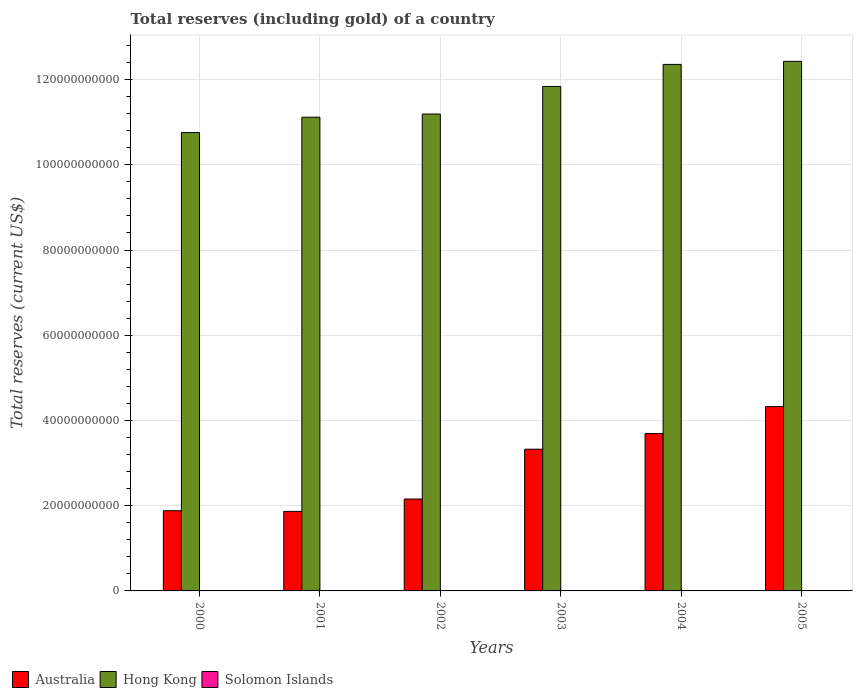How many bars are there on the 3rd tick from the right?
Offer a terse response. 3. What is the label of the 2nd group of bars from the left?
Keep it short and to the point. 2001. In how many cases, is the number of bars for a given year not equal to the number of legend labels?
Give a very brief answer. 0. What is the total reserves (including gold) in Hong Kong in 2005?
Offer a very short reply. 1.24e+11. Across all years, what is the maximum total reserves (including gold) in Solomon Islands?
Keep it short and to the point. 9.48e+07. Across all years, what is the minimum total reserves (including gold) in Australia?
Your answer should be compact. 1.87e+1. What is the total total reserves (including gold) in Australia in the graph?
Your answer should be very brief. 1.72e+11. What is the difference between the total reserves (including gold) in Australia in 2001 and that in 2002?
Offer a terse response. -2.90e+09. What is the difference between the total reserves (including gold) in Hong Kong in 2003 and the total reserves (including gold) in Australia in 2001?
Keep it short and to the point. 9.97e+1. What is the average total reserves (including gold) in Solomon Islands per year?
Provide a succinct answer. 4.67e+07. In the year 2003, what is the difference between the total reserves (including gold) in Solomon Islands and total reserves (including gold) in Hong Kong?
Give a very brief answer. -1.18e+11. In how many years, is the total reserves (including gold) in Hong Kong greater than 36000000000 US$?
Offer a terse response. 6. What is the ratio of the total reserves (including gold) in Solomon Islands in 2000 to that in 2001?
Give a very brief answer. 1.77. What is the difference between the highest and the second highest total reserves (including gold) in Australia?
Offer a terse response. 6.33e+09. What is the difference between the highest and the lowest total reserves (including gold) in Solomon Islands?
Offer a very short reply. 7.68e+07. In how many years, is the total reserves (including gold) in Australia greater than the average total reserves (including gold) in Australia taken over all years?
Give a very brief answer. 3. What does the 3rd bar from the left in 2003 represents?
Your answer should be compact. Solomon Islands. What does the 2nd bar from the right in 2003 represents?
Your response must be concise. Hong Kong. Is it the case that in every year, the sum of the total reserves (including gold) in Australia and total reserves (including gold) in Hong Kong is greater than the total reserves (including gold) in Solomon Islands?
Provide a succinct answer. Yes. How many bars are there?
Keep it short and to the point. 18. Are all the bars in the graph horizontal?
Give a very brief answer. No. How many years are there in the graph?
Give a very brief answer. 6. What is the difference between two consecutive major ticks on the Y-axis?
Your response must be concise. 2.00e+1. Are the values on the major ticks of Y-axis written in scientific E-notation?
Your response must be concise. No. Does the graph contain any zero values?
Provide a succinct answer. No. Does the graph contain grids?
Make the answer very short. Yes. Where does the legend appear in the graph?
Give a very brief answer. Bottom left. How many legend labels are there?
Make the answer very short. 3. What is the title of the graph?
Give a very brief answer. Total reserves (including gold) of a country. Does "Chile" appear as one of the legend labels in the graph?
Your answer should be very brief. No. What is the label or title of the Y-axis?
Your response must be concise. Total reserves (current US$). What is the Total reserves (current US$) in Australia in 2000?
Give a very brief answer. 1.88e+1. What is the Total reserves (current US$) of Hong Kong in 2000?
Make the answer very short. 1.08e+11. What is the Total reserves (current US$) of Solomon Islands in 2000?
Keep it short and to the point. 3.20e+07. What is the Total reserves (current US$) of Australia in 2001?
Provide a short and direct response. 1.87e+1. What is the Total reserves (current US$) in Hong Kong in 2001?
Keep it short and to the point. 1.11e+11. What is the Total reserves (current US$) of Solomon Islands in 2001?
Provide a short and direct response. 1.81e+07. What is the Total reserves (current US$) of Australia in 2002?
Provide a succinct answer. 2.16e+1. What is the Total reserves (current US$) in Hong Kong in 2002?
Provide a short and direct response. 1.12e+11. What is the Total reserves (current US$) of Solomon Islands in 2002?
Your answer should be very brief. 1.87e+07. What is the Total reserves (current US$) of Australia in 2003?
Offer a very short reply. 3.33e+1. What is the Total reserves (current US$) of Hong Kong in 2003?
Offer a very short reply. 1.18e+11. What is the Total reserves (current US$) in Solomon Islands in 2003?
Offer a very short reply. 3.70e+07. What is the Total reserves (current US$) in Australia in 2004?
Your response must be concise. 3.69e+1. What is the Total reserves (current US$) in Hong Kong in 2004?
Your answer should be compact. 1.24e+11. What is the Total reserves (current US$) of Solomon Islands in 2004?
Make the answer very short. 7.98e+07. What is the Total reserves (current US$) of Australia in 2005?
Ensure brevity in your answer.  4.33e+1. What is the Total reserves (current US$) of Hong Kong in 2005?
Provide a short and direct response. 1.24e+11. What is the Total reserves (current US$) of Solomon Islands in 2005?
Give a very brief answer. 9.48e+07. Across all years, what is the maximum Total reserves (current US$) in Australia?
Give a very brief answer. 4.33e+1. Across all years, what is the maximum Total reserves (current US$) in Hong Kong?
Make the answer very short. 1.24e+11. Across all years, what is the maximum Total reserves (current US$) in Solomon Islands?
Your answer should be very brief. 9.48e+07. Across all years, what is the minimum Total reserves (current US$) in Australia?
Keep it short and to the point. 1.87e+1. Across all years, what is the minimum Total reserves (current US$) of Hong Kong?
Offer a terse response. 1.08e+11. Across all years, what is the minimum Total reserves (current US$) of Solomon Islands?
Your answer should be very brief. 1.81e+07. What is the total Total reserves (current US$) of Australia in the graph?
Provide a succinct answer. 1.72e+11. What is the total Total reserves (current US$) in Hong Kong in the graph?
Offer a terse response. 6.97e+11. What is the total Total reserves (current US$) of Solomon Islands in the graph?
Offer a terse response. 2.80e+08. What is the difference between the Total reserves (current US$) of Australia in 2000 and that in 2001?
Your answer should be very brief. 1.58e+08. What is the difference between the Total reserves (current US$) of Hong Kong in 2000 and that in 2001?
Your answer should be very brief. -3.61e+09. What is the difference between the Total reserves (current US$) of Solomon Islands in 2000 and that in 2001?
Offer a very short reply. 1.40e+07. What is the difference between the Total reserves (current US$) in Australia in 2000 and that in 2002?
Offer a very short reply. -2.75e+09. What is the difference between the Total reserves (current US$) of Hong Kong in 2000 and that in 2002?
Your answer should be very brief. -4.36e+09. What is the difference between the Total reserves (current US$) in Solomon Islands in 2000 and that in 2002?
Offer a very short reply. 1.34e+07. What is the difference between the Total reserves (current US$) in Australia in 2000 and that in 2003?
Ensure brevity in your answer.  -1.44e+1. What is the difference between the Total reserves (current US$) of Hong Kong in 2000 and that in 2003?
Your response must be concise. -1.08e+1. What is the difference between the Total reserves (current US$) of Solomon Islands in 2000 and that in 2003?
Provide a succinct answer. -4.96e+06. What is the difference between the Total reserves (current US$) of Australia in 2000 and that in 2004?
Your answer should be compact. -1.81e+1. What is the difference between the Total reserves (current US$) in Hong Kong in 2000 and that in 2004?
Your answer should be compact. -1.60e+1. What is the difference between the Total reserves (current US$) of Solomon Islands in 2000 and that in 2004?
Your answer should be compact. -4.78e+07. What is the difference between the Total reserves (current US$) of Australia in 2000 and that in 2005?
Ensure brevity in your answer.  -2.44e+1. What is the difference between the Total reserves (current US$) of Hong Kong in 2000 and that in 2005?
Make the answer very short. -1.67e+1. What is the difference between the Total reserves (current US$) of Solomon Islands in 2000 and that in 2005?
Your answer should be very brief. -6.28e+07. What is the difference between the Total reserves (current US$) in Australia in 2001 and that in 2002?
Your answer should be compact. -2.90e+09. What is the difference between the Total reserves (current US$) in Hong Kong in 2001 and that in 2002?
Your answer should be compact. -7.45e+08. What is the difference between the Total reserves (current US$) in Solomon Islands in 2001 and that in 2002?
Keep it short and to the point. -6.17e+05. What is the difference between the Total reserves (current US$) of Australia in 2001 and that in 2003?
Ensure brevity in your answer.  -1.46e+1. What is the difference between the Total reserves (current US$) of Hong Kong in 2001 and that in 2003?
Give a very brief answer. -7.21e+09. What is the difference between the Total reserves (current US$) in Solomon Islands in 2001 and that in 2003?
Offer a terse response. -1.89e+07. What is the difference between the Total reserves (current US$) of Australia in 2001 and that in 2004?
Provide a succinct answer. -1.83e+1. What is the difference between the Total reserves (current US$) in Hong Kong in 2001 and that in 2004?
Your answer should be very brief. -1.24e+1. What is the difference between the Total reserves (current US$) of Solomon Islands in 2001 and that in 2004?
Offer a very short reply. -6.17e+07. What is the difference between the Total reserves (current US$) of Australia in 2001 and that in 2005?
Offer a terse response. -2.46e+1. What is the difference between the Total reserves (current US$) in Hong Kong in 2001 and that in 2005?
Keep it short and to the point. -1.31e+1. What is the difference between the Total reserves (current US$) in Solomon Islands in 2001 and that in 2005?
Offer a terse response. -7.68e+07. What is the difference between the Total reserves (current US$) in Australia in 2002 and that in 2003?
Your answer should be very brief. -1.17e+1. What is the difference between the Total reserves (current US$) in Hong Kong in 2002 and that in 2003?
Your response must be concise. -6.47e+09. What is the difference between the Total reserves (current US$) of Solomon Islands in 2002 and that in 2003?
Your answer should be very brief. -1.83e+07. What is the difference between the Total reserves (current US$) in Australia in 2002 and that in 2004?
Keep it short and to the point. -1.54e+1. What is the difference between the Total reserves (current US$) in Hong Kong in 2002 and that in 2004?
Your response must be concise. -1.17e+1. What is the difference between the Total reserves (current US$) of Solomon Islands in 2002 and that in 2004?
Make the answer very short. -6.11e+07. What is the difference between the Total reserves (current US$) in Australia in 2002 and that in 2005?
Provide a short and direct response. -2.17e+1. What is the difference between the Total reserves (current US$) in Hong Kong in 2002 and that in 2005?
Your answer should be very brief. -1.24e+1. What is the difference between the Total reserves (current US$) in Solomon Islands in 2002 and that in 2005?
Offer a terse response. -7.61e+07. What is the difference between the Total reserves (current US$) of Australia in 2003 and that in 2004?
Make the answer very short. -3.67e+09. What is the difference between the Total reserves (current US$) in Hong Kong in 2003 and that in 2004?
Your answer should be compact. -5.18e+09. What is the difference between the Total reserves (current US$) of Solomon Islands in 2003 and that in 2004?
Your response must be concise. -4.28e+07. What is the difference between the Total reserves (current US$) in Australia in 2003 and that in 2005?
Your answer should be compact. -1.00e+1. What is the difference between the Total reserves (current US$) of Hong Kong in 2003 and that in 2005?
Provide a succinct answer. -5.89e+09. What is the difference between the Total reserves (current US$) in Solomon Islands in 2003 and that in 2005?
Offer a terse response. -5.78e+07. What is the difference between the Total reserves (current US$) in Australia in 2004 and that in 2005?
Your answer should be very brief. -6.33e+09. What is the difference between the Total reserves (current US$) of Hong Kong in 2004 and that in 2005?
Offer a very short reply. -7.09e+08. What is the difference between the Total reserves (current US$) in Solomon Islands in 2004 and that in 2005?
Provide a succinct answer. -1.50e+07. What is the difference between the Total reserves (current US$) in Australia in 2000 and the Total reserves (current US$) in Hong Kong in 2001?
Make the answer very short. -9.24e+1. What is the difference between the Total reserves (current US$) of Australia in 2000 and the Total reserves (current US$) of Solomon Islands in 2001?
Keep it short and to the point. 1.88e+1. What is the difference between the Total reserves (current US$) in Hong Kong in 2000 and the Total reserves (current US$) in Solomon Islands in 2001?
Make the answer very short. 1.08e+11. What is the difference between the Total reserves (current US$) of Australia in 2000 and the Total reserves (current US$) of Hong Kong in 2002?
Your answer should be compact. -9.31e+1. What is the difference between the Total reserves (current US$) of Australia in 2000 and the Total reserves (current US$) of Solomon Islands in 2002?
Offer a terse response. 1.88e+1. What is the difference between the Total reserves (current US$) in Hong Kong in 2000 and the Total reserves (current US$) in Solomon Islands in 2002?
Provide a succinct answer. 1.08e+11. What is the difference between the Total reserves (current US$) in Australia in 2000 and the Total reserves (current US$) in Hong Kong in 2003?
Make the answer very short. -9.96e+1. What is the difference between the Total reserves (current US$) in Australia in 2000 and the Total reserves (current US$) in Solomon Islands in 2003?
Your response must be concise. 1.88e+1. What is the difference between the Total reserves (current US$) of Hong Kong in 2000 and the Total reserves (current US$) of Solomon Islands in 2003?
Offer a terse response. 1.08e+11. What is the difference between the Total reserves (current US$) in Australia in 2000 and the Total reserves (current US$) in Hong Kong in 2004?
Give a very brief answer. -1.05e+11. What is the difference between the Total reserves (current US$) in Australia in 2000 and the Total reserves (current US$) in Solomon Islands in 2004?
Your response must be concise. 1.87e+1. What is the difference between the Total reserves (current US$) in Hong Kong in 2000 and the Total reserves (current US$) in Solomon Islands in 2004?
Your answer should be compact. 1.07e+11. What is the difference between the Total reserves (current US$) in Australia in 2000 and the Total reserves (current US$) in Hong Kong in 2005?
Your answer should be compact. -1.05e+11. What is the difference between the Total reserves (current US$) in Australia in 2000 and the Total reserves (current US$) in Solomon Islands in 2005?
Ensure brevity in your answer.  1.87e+1. What is the difference between the Total reserves (current US$) in Hong Kong in 2000 and the Total reserves (current US$) in Solomon Islands in 2005?
Offer a very short reply. 1.07e+11. What is the difference between the Total reserves (current US$) in Australia in 2001 and the Total reserves (current US$) in Hong Kong in 2002?
Offer a very short reply. -9.33e+1. What is the difference between the Total reserves (current US$) of Australia in 2001 and the Total reserves (current US$) of Solomon Islands in 2002?
Provide a succinct answer. 1.86e+1. What is the difference between the Total reserves (current US$) in Hong Kong in 2001 and the Total reserves (current US$) in Solomon Islands in 2002?
Give a very brief answer. 1.11e+11. What is the difference between the Total reserves (current US$) of Australia in 2001 and the Total reserves (current US$) of Hong Kong in 2003?
Provide a short and direct response. -9.97e+1. What is the difference between the Total reserves (current US$) in Australia in 2001 and the Total reserves (current US$) in Solomon Islands in 2003?
Keep it short and to the point. 1.86e+1. What is the difference between the Total reserves (current US$) of Hong Kong in 2001 and the Total reserves (current US$) of Solomon Islands in 2003?
Offer a very short reply. 1.11e+11. What is the difference between the Total reserves (current US$) of Australia in 2001 and the Total reserves (current US$) of Hong Kong in 2004?
Ensure brevity in your answer.  -1.05e+11. What is the difference between the Total reserves (current US$) of Australia in 2001 and the Total reserves (current US$) of Solomon Islands in 2004?
Offer a very short reply. 1.86e+1. What is the difference between the Total reserves (current US$) of Hong Kong in 2001 and the Total reserves (current US$) of Solomon Islands in 2004?
Ensure brevity in your answer.  1.11e+11. What is the difference between the Total reserves (current US$) of Australia in 2001 and the Total reserves (current US$) of Hong Kong in 2005?
Provide a succinct answer. -1.06e+11. What is the difference between the Total reserves (current US$) in Australia in 2001 and the Total reserves (current US$) in Solomon Islands in 2005?
Offer a terse response. 1.86e+1. What is the difference between the Total reserves (current US$) in Hong Kong in 2001 and the Total reserves (current US$) in Solomon Islands in 2005?
Ensure brevity in your answer.  1.11e+11. What is the difference between the Total reserves (current US$) of Australia in 2002 and the Total reserves (current US$) of Hong Kong in 2003?
Offer a terse response. -9.68e+1. What is the difference between the Total reserves (current US$) of Australia in 2002 and the Total reserves (current US$) of Solomon Islands in 2003?
Your answer should be compact. 2.15e+1. What is the difference between the Total reserves (current US$) of Hong Kong in 2002 and the Total reserves (current US$) of Solomon Islands in 2003?
Provide a short and direct response. 1.12e+11. What is the difference between the Total reserves (current US$) in Australia in 2002 and the Total reserves (current US$) in Hong Kong in 2004?
Give a very brief answer. -1.02e+11. What is the difference between the Total reserves (current US$) of Australia in 2002 and the Total reserves (current US$) of Solomon Islands in 2004?
Give a very brief answer. 2.15e+1. What is the difference between the Total reserves (current US$) in Hong Kong in 2002 and the Total reserves (current US$) in Solomon Islands in 2004?
Ensure brevity in your answer.  1.12e+11. What is the difference between the Total reserves (current US$) of Australia in 2002 and the Total reserves (current US$) of Hong Kong in 2005?
Your answer should be very brief. -1.03e+11. What is the difference between the Total reserves (current US$) of Australia in 2002 and the Total reserves (current US$) of Solomon Islands in 2005?
Provide a succinct answer. 2.15e+1. What is the difference between the Total reserves (current US$) in Hong Kong in 2002 and the Total reserves (current US$) in Solomon Islands in 2005?
Your response must be concise. 1.12e+11. What is the difference between the Total reserves (current US$) in Australia in 2003 and the Total reserves (current US$) in Hong Kong in 2004?
Offer a very short reply. -9.03e+1. What is the difference between the Total reserves (current US$) of Australia in 2003 and the Total reserves (current US$) of Solomon Islands in 2004?
Your answer should be very brief. 3.32e+1. What is the difference between the Total reserves (current US$) of Hong Kong in 2003 and the Total reserves (current US$) of Solomon Islands in 2004?
Provide a succinct answer. 1.18e+11. What is the difference between the Total reserves (current US$) of Australia in 2003 and the Total reserves (current US$) of Hong Kong in 2005?
Make the answer very short. -9.10e+1. What is the difference between the Total reserves (current US$) in Australia in 2003 and the Total reserves (current US$) in Solomon Islands in 2005?
Give a very brief answer. 3.32e+1. What is the difference between the Total reserves (current US$) in Hong Kong in 2003 and the Total reserves (current US$) in Solomon Islands in 2005?
Offer a terse response. 1.18e+11. What is the difference between the Total reserves (current US$) in Australia in 2004 and the Total reserves (current US$) in Hong Kong in 2005?
Make the answer very short. -8.74e+1. What is the difference between the Total reserves (current US$) in Australia in 2004 and the Total reserves (current US$) in Solomon Islands in 2005?
Give a very brief answer. 3.68e+1. What is the difference between the Total reserves (current US$) of Hong Kong in 2004 and the Total reserves (current US$) of Solomon Islands in 2005?
Your answer should be very brief. 1.23e+11. What is the average Total reserves (current US$) in Australia per year?
Make the answer very short. 2.87e+1. What is the average Total reserves (current US$) in Hong Kong per year?
Your answer should be compact. 1.16e+11. What is the average Total reserves (current US$) in Solomon Islands per year?
Offer a very short reply. 4.67e+07. In the year 2000, what is the difference between the Total reserves (current US$) in Australia and Total reserves (current US$) in Hong Kong?
Your response must be concise. -8.87e+1. In the year 2000, what is the difference between the Total reserves (current US$) of Australia and Total reserves (current US$) of Solomon Islands?
Offer a very short reply. 1.88e+1. In the year 2000, what is the difference between the Total reserves (current US$) of Hong Kong and Total reserves (current US$) of Solomon Islands?
Make the answer very short. 1.08e+11. In the year 2001, what is the difference between the Total reserves (current US$) of Australia and Total reserves (current US$) of Hong Kong?
Offer a terse response. -9.25e+1. In the year 2001, what is the difference between the Total reserves (current US$) of Australia and Total reserves (current US$) of Solomon Islands?
Ensure brevity in your answer.  1.86e+1. In the year 2001, what is the difference between the Total reserves (current US$) in Hong Kong and Total reserves (current US$) in Solomon Islands?
Your response must be concise. 1.11e+11. In the year 2002, what is the difference between the Total reserves (current US$) in Australia and Total reserves (current US$) in Hong Kong?
Make the answer very short. -9.04e+1. In the year 2002, what is the difference between the Total reserves (current US$) in Australia and Total reserves (current US$) in Solomon Islands?
Make the answer very short. 2.15e+1. In the year 2002, what is the difference between the Total reserves (current US$) of Hong Kong and Total reserves (current US$) of Solomon Islands?
Ensure brevity in your answer.  1.12e+11. In the year 2003, what is the difference between the Total reserves (current US$) of Australia and Total reserves (current US$) of Hong Kong?
Provide a short and direct response. -8.51e+1. In the year 2003, what is the difference between the Total reserves (current US$) of Australia and Total reserves (current US$) of Solomon Islands?
Offer a terse response. 3.32e+1. In the year 2003, what is the difference between the Total reserves (current US$) in Hong Kong and Total reserves (current US$) in Solomon Islands?
Give a very brief answer. 1.18e+11. In the year 2004, what is the difference between the Total reserves (current US$) in Australia and Total reserves (current US$) in Hong Kong?
Your answer should be compact. -8.66e+1. In the year 2004, what is the difference between the Total reserves (current US$) of Australia and Total reserves (current US$) of Solomon Islands?
Your response must be concise. 3.68e+1. In the year 2004, what is the difference between the Total reserves (current US$) of Hong Kong and Total reserves (current US$) of Solomon Islands?
Offer a very short reply. 1.23e+11. In the year 2005, what is the difference between the Total reserves (current US$) in Australia and Total reserves (current US$) in Hong Kong?
Provide a succinct answer. -8.10e+1. In the year 2005, what is the difference between the Total reserves (current US$) of Australia and Total reserves (current US$) of Solomon Islands?
Make the answer very short. 4.32e+1. In the year 2005, what is the difference between the Total reserves (current US$) of Hong Kong and Total reserves (current US$) of Solomon Islands?
Keep it short and to the point. 1.24e+11. What is the ratio of the Total reserves (current US$) of Australia in 2000 to that in 2001?
Your response must be concise. 1.01. What is the ratio of the Total reserves (current US$) of Hong Kong in 2000 to that in 2001?
Keep it short and to the point. 0.97. What is the ratio of the Total reserves (current US$) of Solomon Islands in 2000 to that in 2001?
Your answer should be very brief. 1.77. What is the ratio of the Total reserves (current US$) of Australia in 2000 to that in 2002?
Ensure brevity in your answer.  0.87. What is the ratio of the Total reserves (current US$) in Hong Kong in 2000 to that in 2002?
Give a very brief answer. 0.96. What is the ratio of the Total reserves (current US$) in Solomon Islands in 2000 to that in 2002?
Keep it short and to the point. 1.71. What is the ratio of the Total reserves (current US$) in Australia in 2000 to that in 2003?
Ensure brevity in your answer.  0.57. What is the ratio of the Total reserves (current US$) of Hong Kong in 2000 to that in 2003?
Offer a terse response. 0.91. What is the ratio of the Total reserves (current US$) of Solomon Islands in 2000 to that in 2003?
Make the answer very short. 0.87. What is the ratio of the Total reserves (current US$) in Australia in 2000 to that in 2004?
Provide a succinct answer. 0.51. What is the ratio of the Total reserves (current US$) of Hong Kong in 2000 to that in 2004?
Your response must be concise. 0.87. What is the ratio of the Total reserves (current US$) of Solomon Islands in 2000 to that in 2004?
Give a very brief answer. 0.4. What is the ratio of the Total reserves (current US$) in Australia in 2000 to that in 2005?
Make the answer very short. 0.44. What is the ratio of the Total reserves (current US$) in Hong Kong in 2000 to that in 2005?
Keep it short and to the point. 0.87. What is the ratio of the Total reserves (current US$) in Solomon Islands in 2000 to that in 2005?
Keep it short and to the point. 0.34. What is the ratio of the Total reserves (current US$) in Australia in 2001 to that in 2002?
Offer a very short reply. 0.87. What is the ratio of the Total reserves (current US$) of Solomon Islands in 2001 to that in 2002?
Ensure brevity in your answer.  0.97. What is the ratio of the Total reserves (current US$) in Australia in 2001 to that in 2003?
Your response must be concise. 0.56. What is the ratio of the Total reserves (current US$) of Hong Kong in 2001 to that in 2003?
Ensure brevity in your answer.  0.94. What is the ratio of the Total reserves (current US$) in Solomon Islands in 2001 to that in 2003?
Offer a very short reply. 0.49. What is the ratio of the Total reserves (current US$) in Australia in 2001 to that in 2004?
Keep it short and to the point. 0.51. What is the ratio of the Total reserves (current US$) in Hong Kong in 2001 to that in 2004?
Provide a short and direct response. 0.9. What is the ratio of the Total reserves (current US$) of Solomon Islands in 2001 to that in 2004?
Offer a terse response. 0.23. What is the ratio of the Total reserves (current US$) in Australia in 2001 to that in 2005?
Ensure brevity in your answer.  0.43. What is the ratio of the Total reserves (current US$) in Hong Kong in 2001 to that in 2005?
Provide a short and direct response. 0.89. What is the ratio of the Total reserves (current US$) in Solomon Islands in 2001 to that in 2005?
Ensure brevity in your answer.  0.19. What is the ratio of the Total reserves (current US$) in Australia in 2002 to that in 2003?
Your answer should be very brief. 0.65. What is the ratio of the Total reserves (current US$) of Hong Kong in 2002 to that in 2003?
Your response must be concise. 0.95. What is the ratio of the Total reserves (current US$) in Solomon Islands in 2002 to that in 2003?
Ensure brevity in your answer.  0.51. What is the ratio of the Total reserves (current US$) of Australia in 2002 to that in 2004?
Give a very brief answer. 0.58. What is the ratio of the Total reserves (current US$) of Hong Kong in 2002 to that in 2004?
Provide a succinct answer. 0.91. What is the ratio of the Total reserves (current US$) of Solomon Islands in 2002 to that in 2004?
Make the answer very short. 0.23. What is the ratio of the Total reserves (current US$) in Australia in 2002 to that in 2005?
Offer a terse response. 0.5. What is the ratio of the Total reserves (current US$) in Hong Kong in 2002 to that in 2005?
Provide a succinct answer. 0.9. What is the ratio of the Total reserves (current US$) of Solomon Islands in 2002 to that in 2005?
Your answer should be compact. 0.2. What is the ratio of the Total reserves (current US$) in Australia in 2003 to that in 2004?
Keep it short and to the point. 0.9. What is the ratio of the Total reserves (current US$) in Hong Kong in 2003 to that in 2004?
Offer a terse response. 0.96. What is the ratio of the Total reserves (current US$) in Solomon Islands in 2003 to that in 2004?
Offer a terse response. 0.46. What is the ratio of the Total reserves (current US$) in Australia in 2003 to that in 2005?
Keep it short and to the point. 0.77. What is the ratio of the Total reserves (current US$) in Hong Kong in 2003 to that in 2005?
Your answer should be very brief. 0.95. What is the ratio of the Total reserves (current US$) of Solomon Islands in 2003 to that in 2005?
Your answer should be compact. 0.39. What is the ratio of the Total reserves (current US$) in Australia in 2004 to that in 2005?
Your answer should be very brief. 0.85. What is the ratio of the Total reserves (current US$) of Hong Kong in 2004 to that in 2005?
Make the answer very short. 0.99. What is the ratio of the Total reserves (current US$) in Solomon Islands in 2004 to that in 2005?
Your answer should be compact. 0.84. What is the difference between the highest and the second highest Total reserves (current US$) of Australia?
Offer a very short reply. 6.33e+09. What is the difference between the highest and the second highest Total reserves (current US$) of Hong Kong?
Give a very brief answer. 7.09e+08. What is the difference between the highest and the second highest Total reserves (current US$) in Solomon Islands?
Make the answer very short. 1.50e+07. What is the difference between the highest and the lowest Total reserves (current US$) of Australia?
Keep it short and to the point. 2.46e+1. What is the difference between the highest and the lowest Total reserves (current US$) in Hong Kong?
Keep it short and to the point. 1.67e+1. What is the difference between the highest and the lowest Total reserves (current US$) in Solomon Islands?
Offer a terse response. 7.68e+07. 